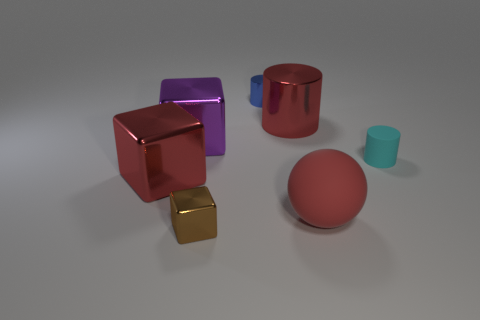What color is the large metal cylinder?
Make the answer very short. Red. What number of other brown objects have the same shape as the brown metal object?
Your answer should be compact. 0. What color is the metallic cylinder that is the same size as the sphere?
Offer a very short reply. Red. Are any tiny yellow cylinders visible?
Provide a short and direct response. No. There is a big thing that is on the left side of the purple cube; what shape is it?
Offer a very short reply. Cube. How many things are both behind the cyan cylinder and to the left of the brown object?
Provide a succinct answer. 1. Are there any tiny blocks made of the same material as the cyan cylinder?
Make the answer very short. No. What is the size of the metal cylinder that is the same color as the big matte thing?
Offer a very short reply. Large. How many balls are tiny cyan objects or purple things?
Offer a terse response. 0. The cyan thing is what size?
Give a very brief answer. Small. 